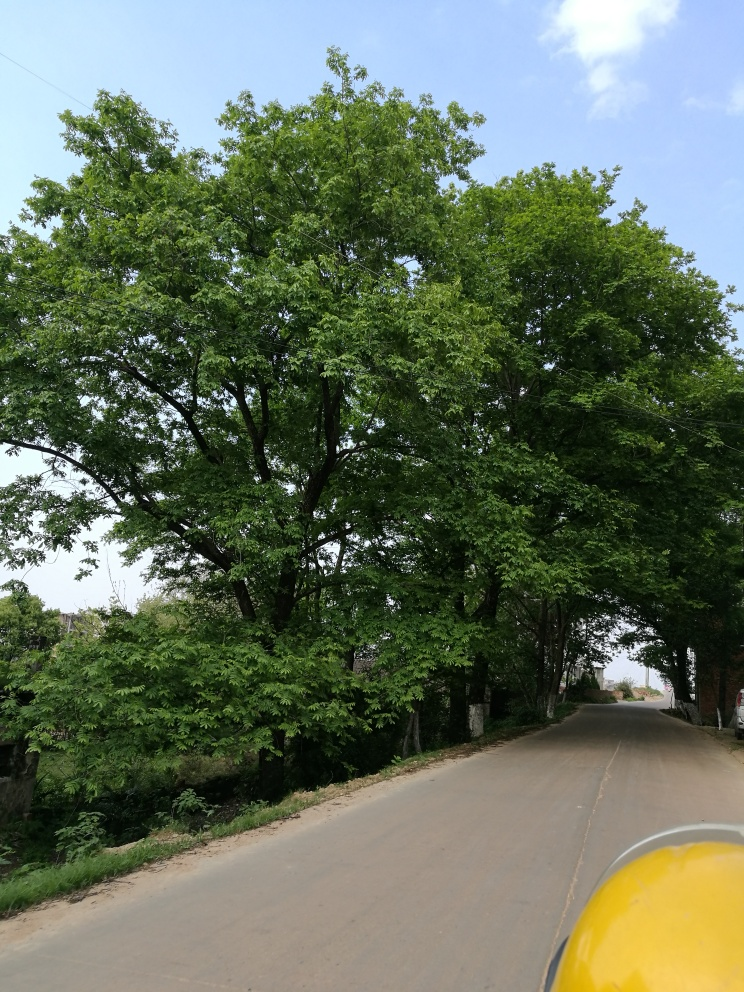Describe the road's condition visible in this image. The road in the image looks to be in good condition, with no visible potholes or large cracks. It's a two-lane road with no visible lane markings which may indicate a low-traffic area. The edges of the road have some overgrowth, and there's a slight curve ahead, emphasizing the need for careful driving in this area. 